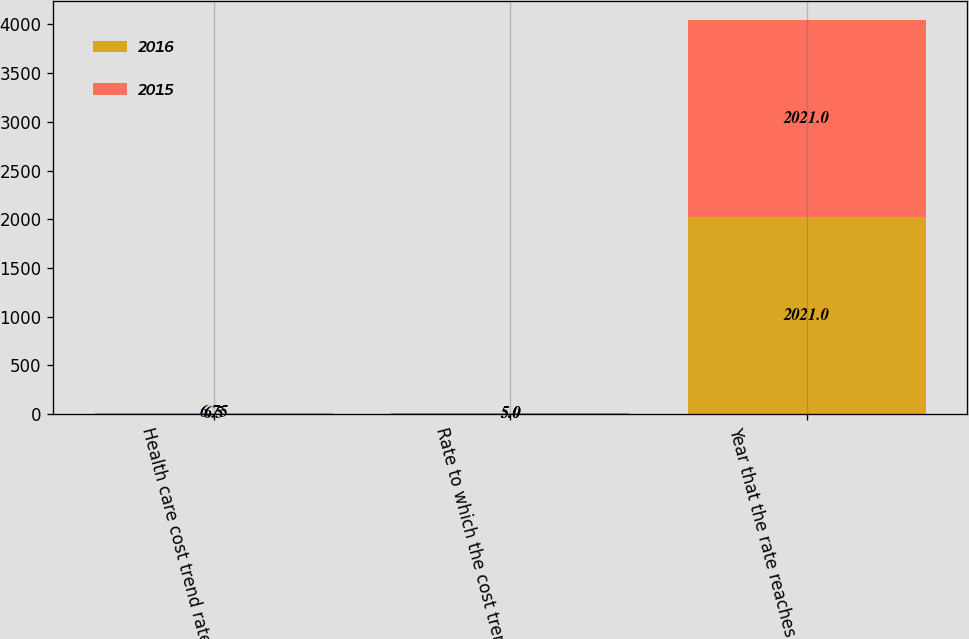Convert chart to OTSL. <chart><loc_0><loc_0><loc_500><loc_500><stacked_bar_chart><ecel><fcel>Health care cost trend rate<fcel>Rate to which the cost trend<fcel>Year that the rate reaches the<nl><fcel>2016<fcel>6.5<fcel>5<fcel>2021<nl><fcel>2015<fcel>6.75<fcel>5<fcel>2021<nl></chart> 